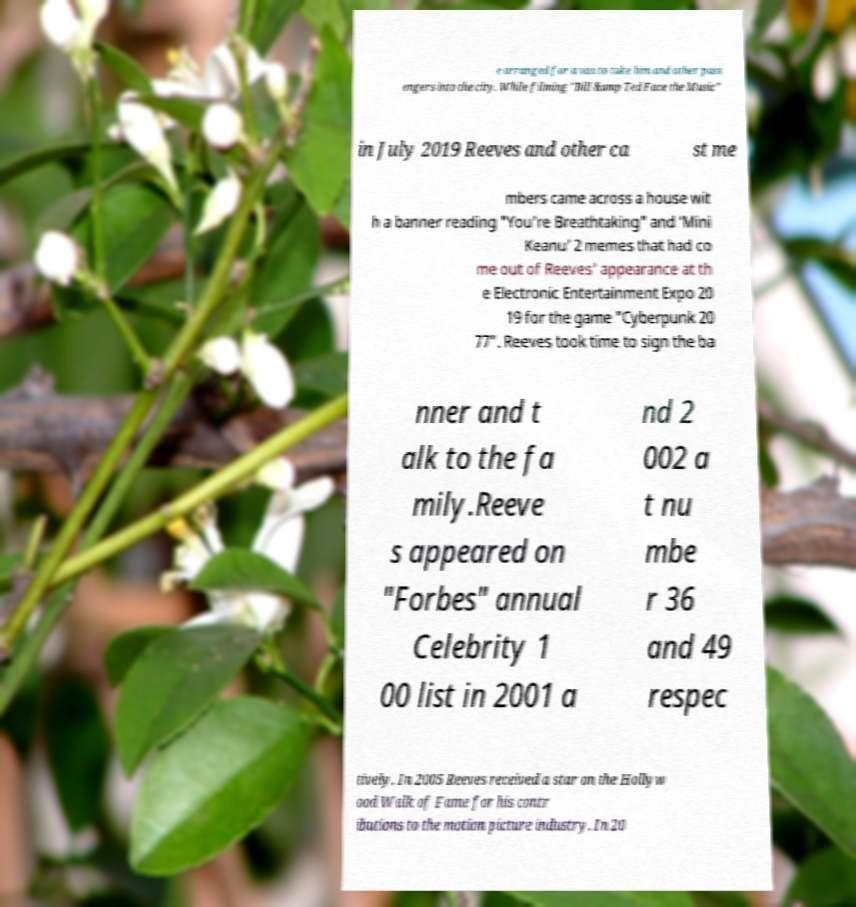Can you accurately transcribe the text from the provided image for me? e arranged for a van to take him and other pass engers into the city. While filming "Bill &amp Ted Face the Music" in July 2019 Reeves and other ca st me mbers came across a house wit h a banner reading "You're Breathtaking" and ‘Mini Keanu’ 2 memes that had co me out of Reeves' appearance at th e Electronic Entertainment Expo 20 19 for the game "Cyberpunk 20 77". Reeves took time to sign the ba nner and t alk to the fa mily.Reeve s appeared on "Forbes" annual Celebrity 1 00 list in 2001 a nd 2 002 a t nu mbe r 36 and 49 respec tively. In 2005 Reeves received a star on the Hollyw ood Walk of Fame for his contr ibutions to the motion picture industry. In 20 